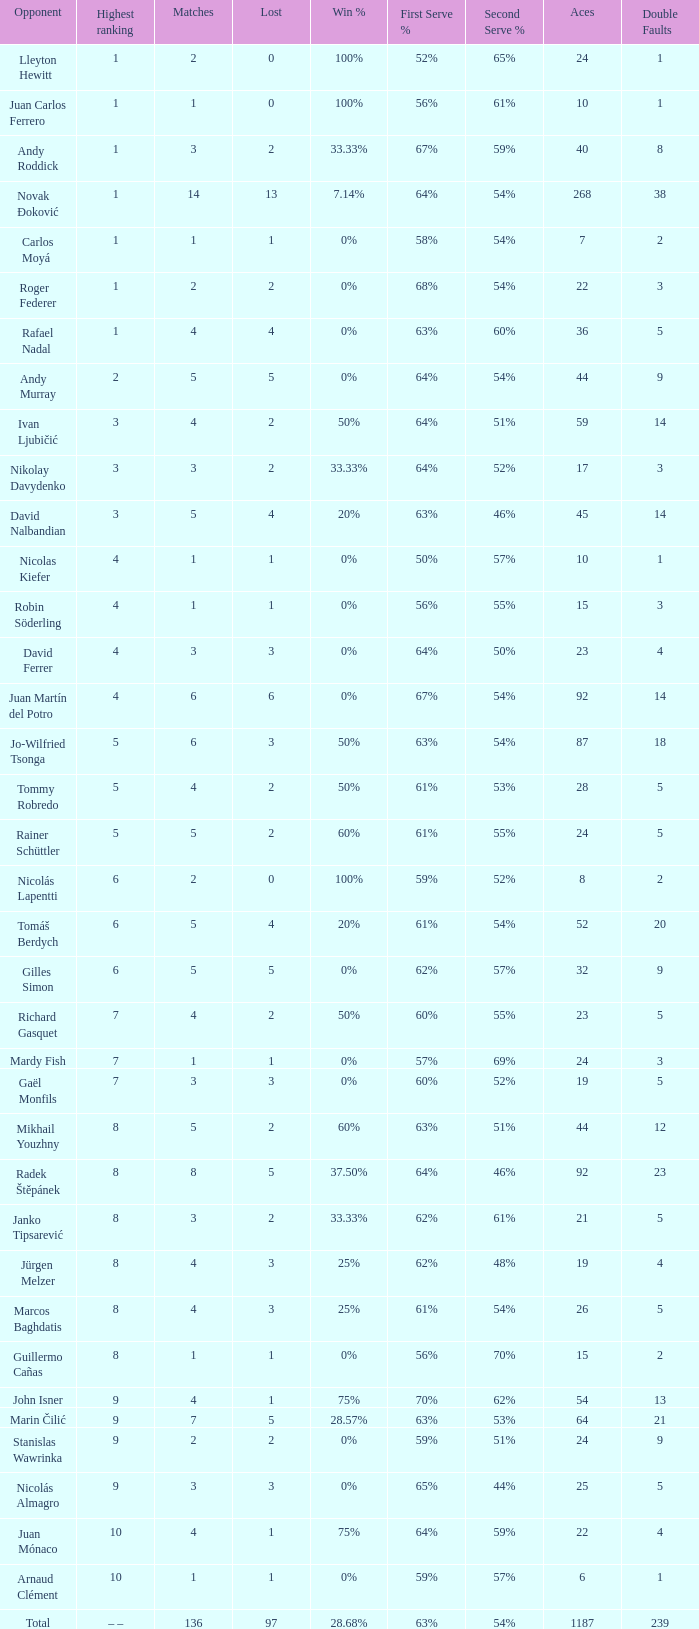What is the smallest number of Matches with less than 97 losses and a Win rate of 28.68%? None. 